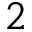<formula> <loc_0><loc_0><loc_500><loc_500>2</formula> 